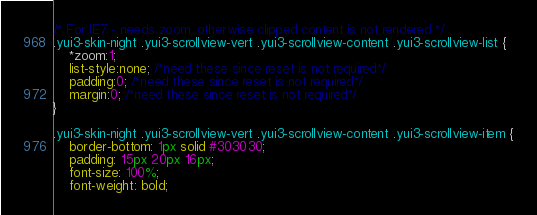<code> <loc_0><loc_0><loc_500><loc_500><_CSS_>/* For IE7 - needs zoom, otherwise clipped content is not rendered */
.yui3-skin-night .yui3-scrollview-vert .yui3-scrollview-content .yui3-scrollview-list {
    *zoom:1;
	list-style:none; /*need these since reset is not required*/
	padding:0; /*need these since reset is not required*/
	margin:0; /*need these since reset is not required*/
}

.yui3-skin-night .yui3-scrollview-vert .yui3-scrollview-content .yui3-scrollview-item {
    border-bottom: 1px solid #303030;
    padding: 15px 20px 16px;
    font-size: 100%;
    font-weight: bold;</code> 